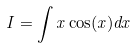<formula> <loc_0><loc_0><loc_500><loc_500>I = \int x \cos ( x ) d x</formula> 